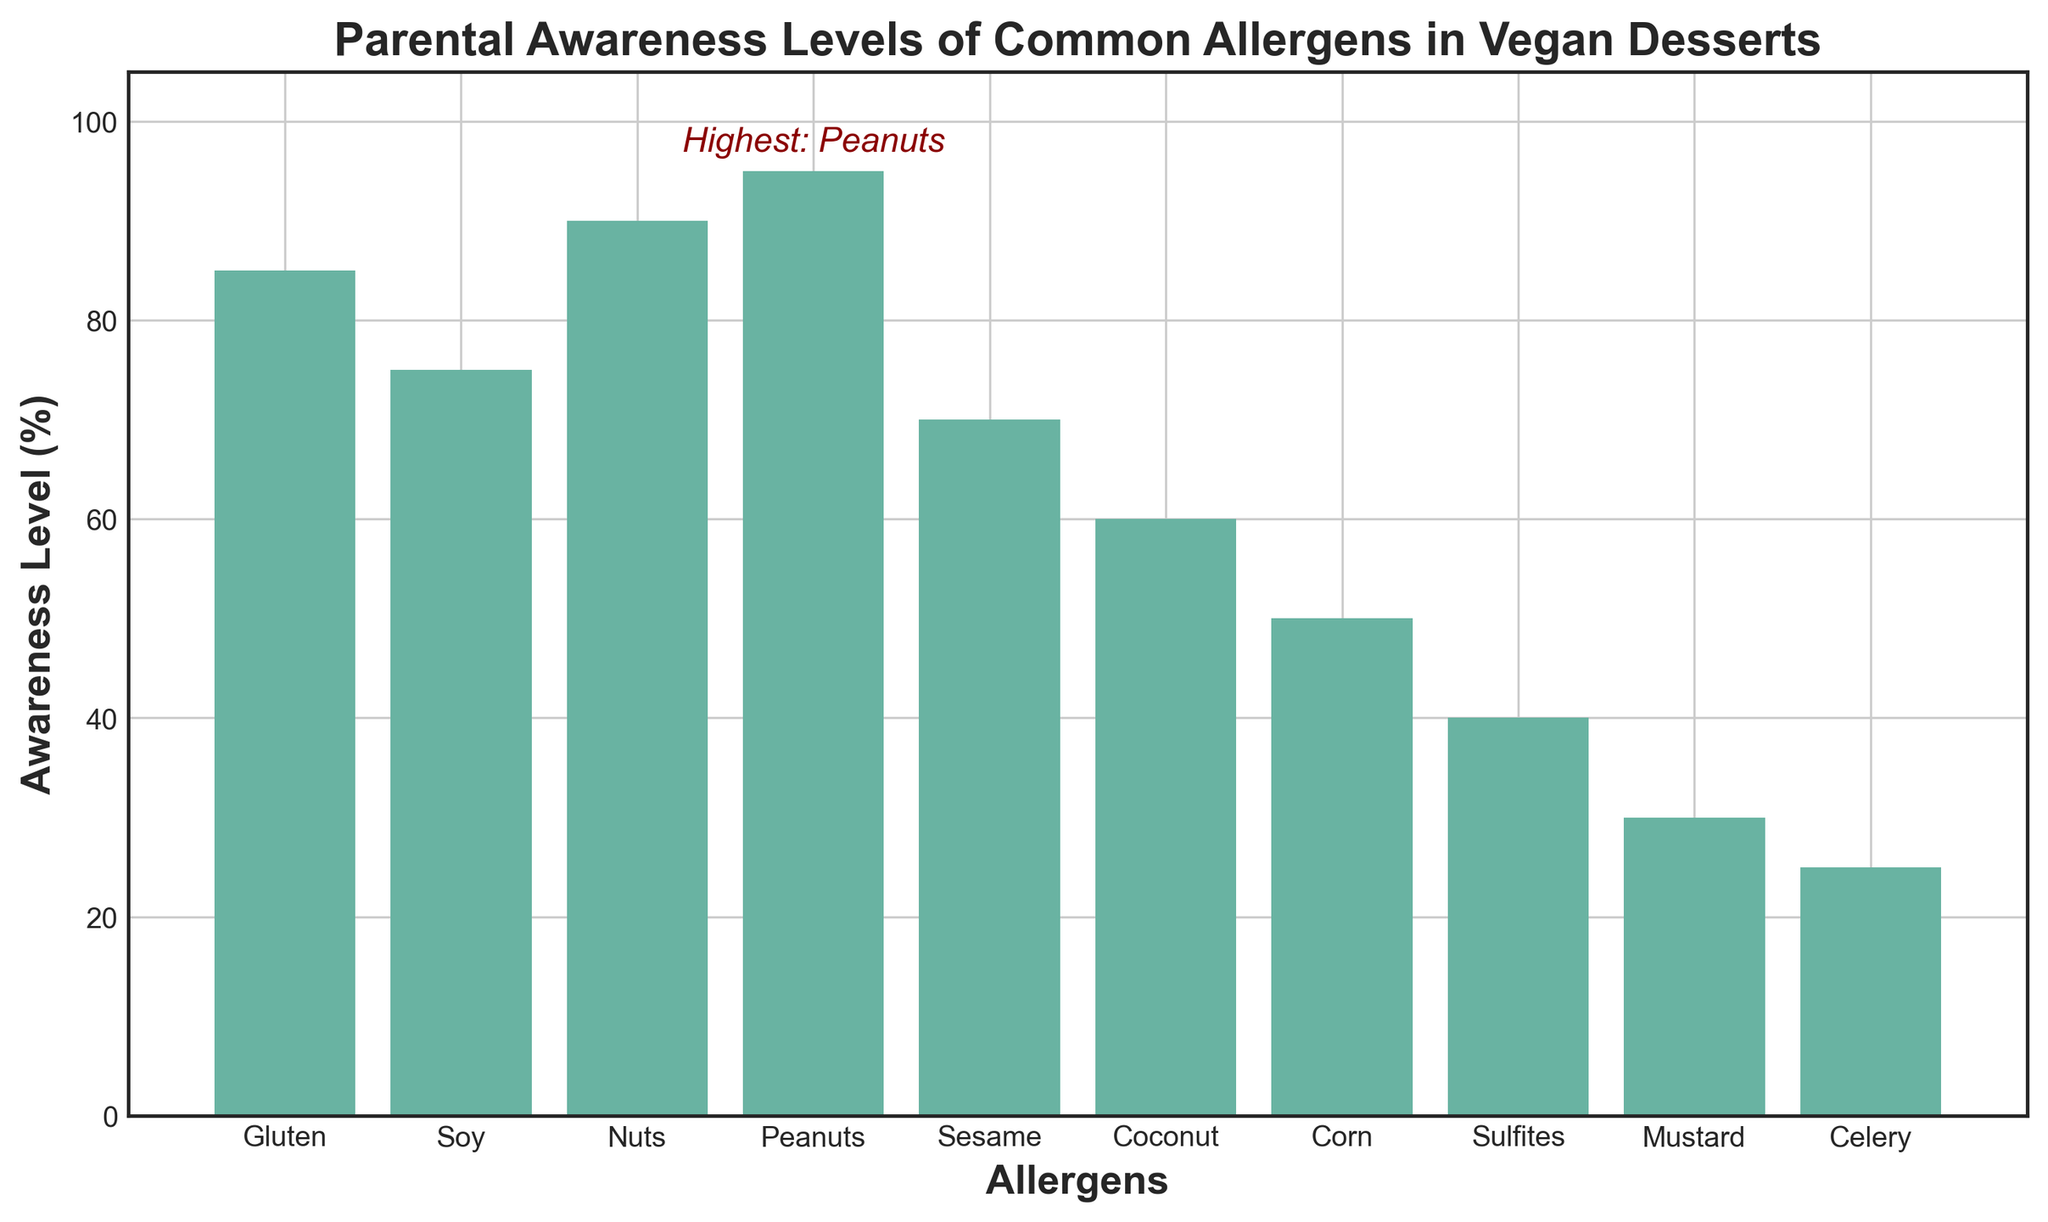What is the parental awareness level for coconut allergens in vegan desserts? To find the awareness level of coconut allergens, locate the bar labeled "Coconut" on the x-axis and read the corresponding y-axis value where the top of the bar reaches.
Answer: 60 Which allergen has the highest parental awareness level in vegan desserts? Locate the bar that reaches the highest point on the y-axis. Then, refer to the x-axis to find the label of the allergen associated with this bar.
Answer: Peanuts How much higher is the awareness level for nuts compared to celery? Find the heights of the bars labeled "Nuts" and "Celery" on the x-axis. Subtract the awareness level of celery (25) from the awareness level of nuts (90).
Answer: 65 What is the combined awareness level for soy and gluten allergens? Locate the bars for "Soy" and "Gluten" on the x-axis. Add their respective values (75 and 85) to get the combined awareness level.
Answer: 160 Which allergens have awareness levels less than 50%? Identify the bars that do not reach the 50% mark on the y-axis and note their corresponding x-axis labels.
Answer: Sulfites, Mustard, Celery On average, what is the parental awareness level for sesame, corn, and mustard allergens? Find the awareness levels for "Sesame" (70), "Corn" (50), and "Mustard" (30). Add these values (70+50+30=150) and then divide by the number of allergens (3) to get the average.
Answer: 50 Which allergens have awareness levels greater than 80%? Identify the bars that surpass the 80% mark on the y-axis and note their corresponding x-axis labels.
Answer: Gluten, Nuts, Peanuts By how much does the awareness level for sesame differ from the awareness level for corn? Locate the bars for "Sesame" and "Corn." Subtract the awareness level of corn (50) from the awareness level of sesame (70).
Answer: 20 What is the lowest parental awareness level of common allergens in vegan desserts? Find the shortest bar and note its awareness level from the y-axis.
Answer: 25 